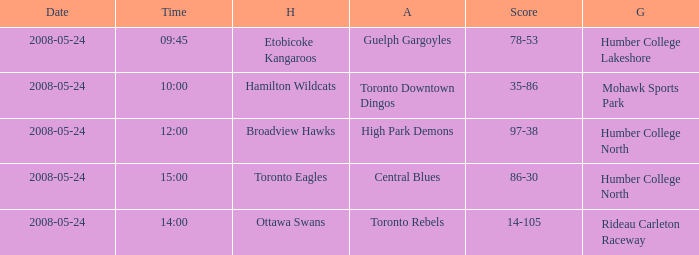On what grounds did the away team of the Toronto Rebels play? Rideau Carleton Raceway. 